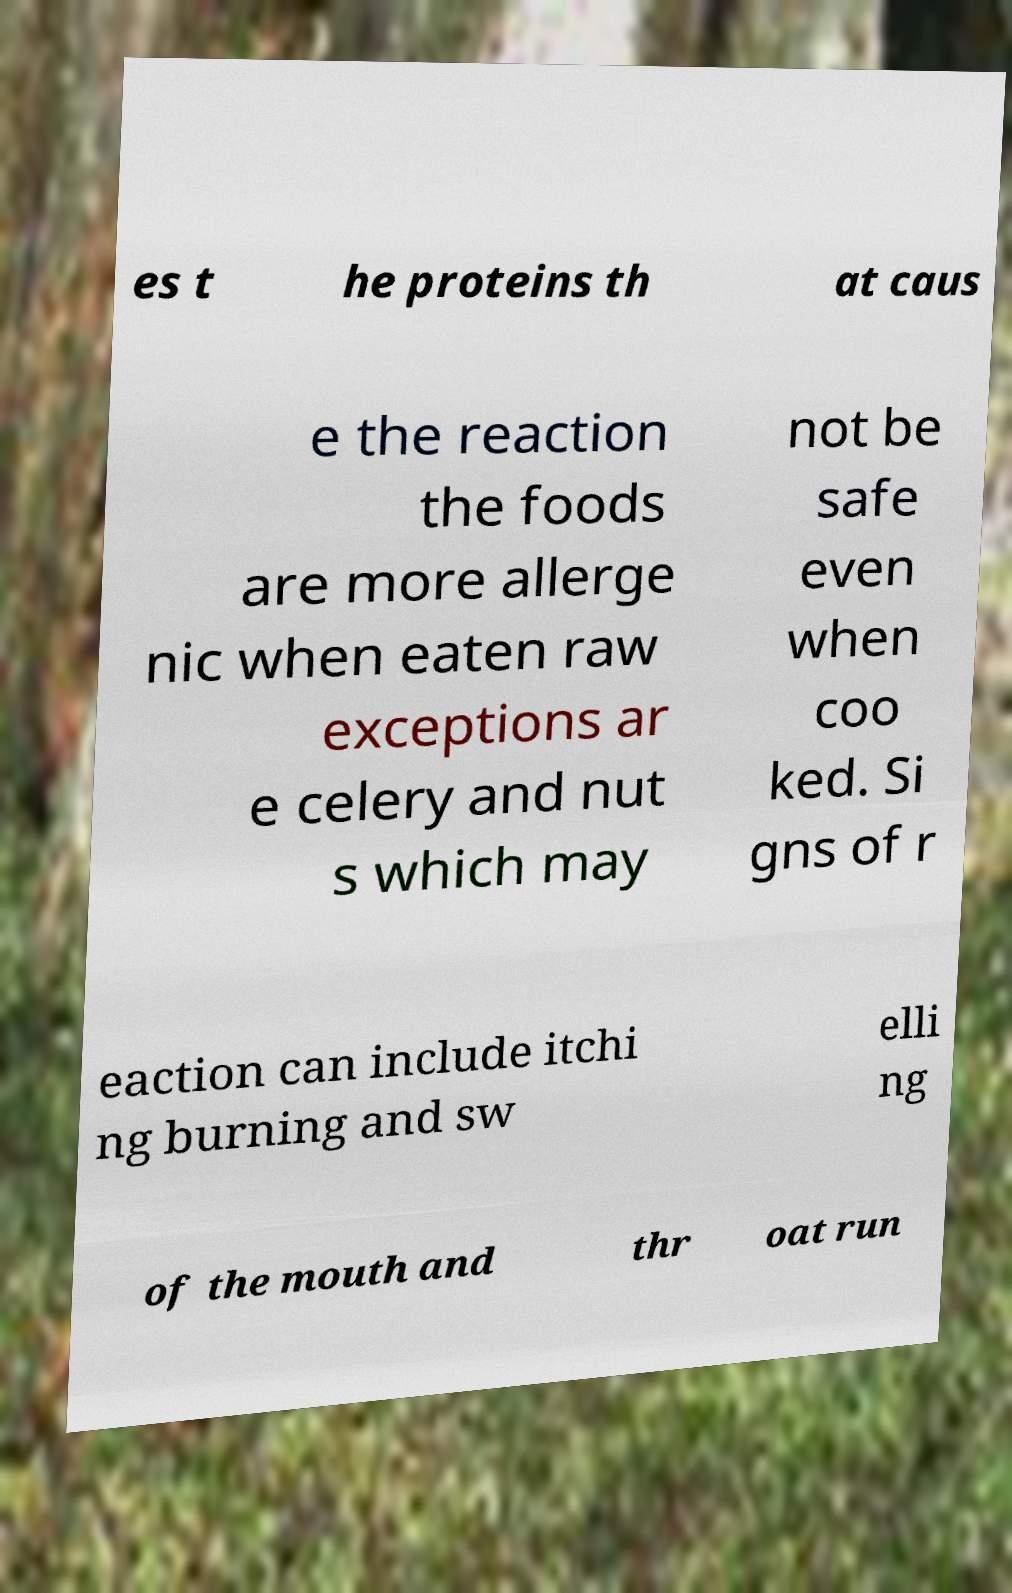Could you extract and type out the text from this image? es t he proteins th at caus e the reaction the foods are more allerge nic when eaten raw exceptions ar e celery and nut s which may not be safe even when coo ked. Si gns of r eaction can include itchi ng burning and sw elli ng of the mouth and thr oat run 